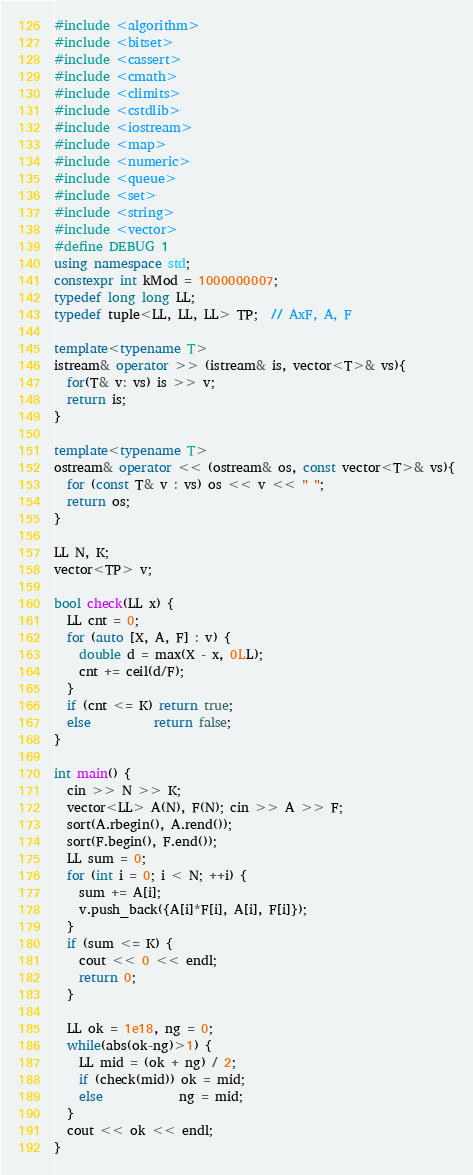Convert code to text. <code><loc_0><loc_0><loc_500><loc_500><_C++_>#include <algorithm>
#include <bitset>
#include <cassert>
#include <cmath>
#include <climits>
#include <cstdlib>
#include <iostream>
#include <map>
#include <numeric>
#include <queue>
#include <set>
#include <string>
#include <vector>
#define DEBUG 1
using namespace std;
constexpr int kMod = 1000000007;
typedef long long LL;
typedef tuple<LL, LL, LL> TP;  // AxF, A, F

template<typename T>
istream& operator >> (istream& is, vector<T>& vs){
  for(T& v: vs) is >> v;
  return is;
}

template<typename T>
ostream& operator << (ostream& os, const vector<T>& vs){
  for (const T& v : vs) os << v << " ";
  return os;
}

LL N, K;
vector<TP> v;

bool check(LL x) {
  LL cnt = 0;
  for (auto [X, A, F] : v) {
    double d = max(X - x, 0LL);
    cnt += ceil(d/F);
  }
  if (cnt <= K) return true;
  else          return false;
}

int main() {
  cin >> N >> K;
  vector<LL> A(N), F(N); cin >> A >> F;
  sort(A.rbegin(), A.rend());
  sort(F.begin(), F.end());
  LL sum = 0;
  for (int i = 0; i < N; ++i) {
    sum += A[i];
    v.push_back({A[i]*F[i], A[i], F[i]});
  }
  if (sum <= K) {
    cout << 0 << endl;
    return 0;
  }

  LL ok = 1e18, ng = 0;
  while(abs(ok-ng)>1) {
    LL mid = (ok + ng) / 2;
    if (check(mid)) ok = mid;
    else            ng = mid;
  }
  cout << ok << endl;
}
</code> 